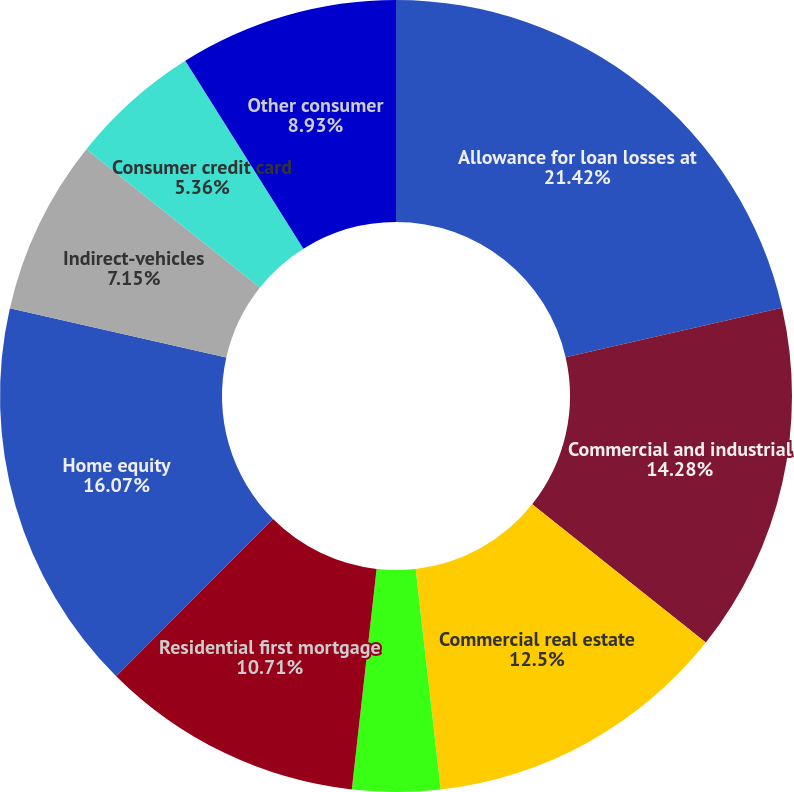<chart> <loc_0><loc_0><loc_500><loc_500><pie_chart><fcel>Allowance for loan losses at<fcel>Commercial and industrial<fcel>Commercial real estate<fcel>Commercial investor real<fcel>Residential first mortgage<fcel>Home equity<fcel>Indirect-vehicles<fcel>Consumer credit card<fcel>Other consumer<nl><fcel>21.42%<fcel>14.28%<fcel>12.5%<fcel>3.58%<fcel>10.71%<fcel>16.07%<fcel>7.15%<fcel>5.36%<fcel>8.93%<nl></chart> 